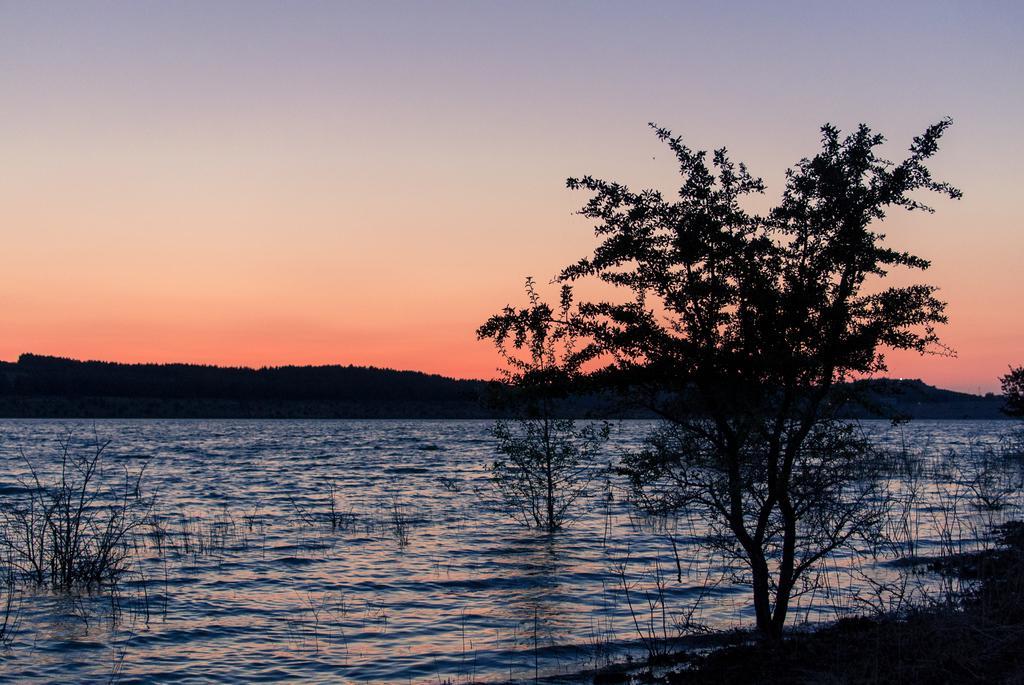Describe this image in one or two sentences. In this picture I can see the lake. On the right we can see the trees and plants. In the background I can see the mountain. At the top I can see the sky. 